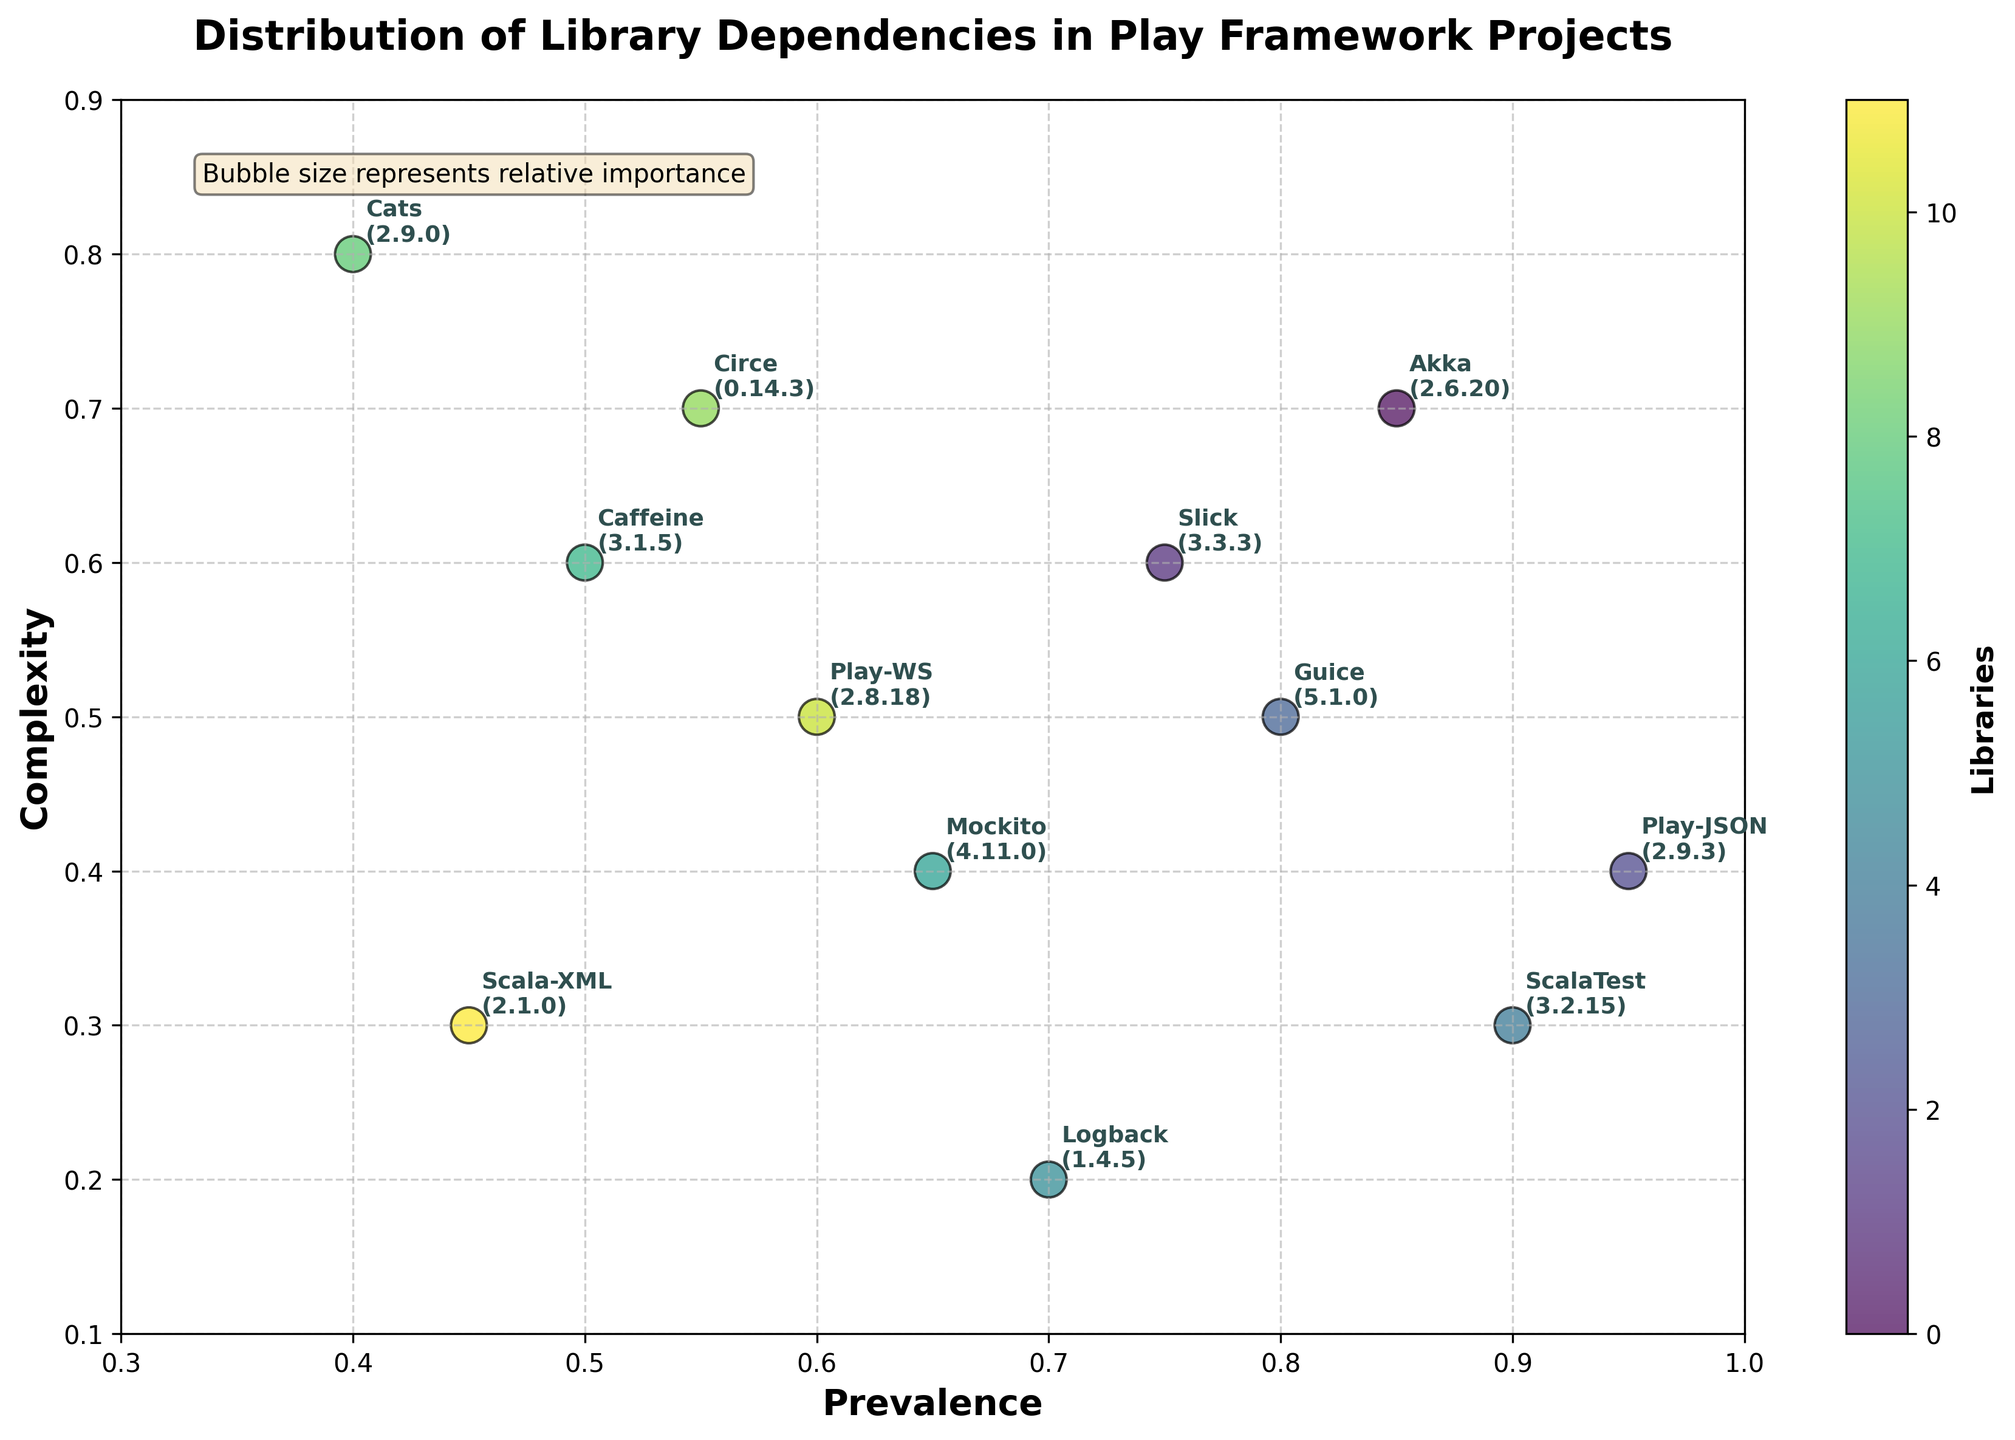What is the title of the plot? The plot's title is prominently displayed at the top center of the figure.
Answer: Distribution of Library Dependencies in Play Framework Projects Which library has the highest prevalence and what is its prevalence value? The label close to the highest point on the x-axis (Prevalence) should be looked at. Looking at the end of the prevalence axis, Play-JSON is the library with the highest prevalence.
Answer: Play-JSON, 0.95 What is the range of complexity values depicted in the plot? Look at the minimum and maximum values on the y-axis (Complexity) to determine the range. Values start from just above 0.1 and go up to just below 0.9.
Answer: 0.1 to 0.9 Which library has the lowest complexity and what is its complexity value? Locate the point that has the lowest position on the y-axis. Logback is the library with the lowest complexity, indicated by its position closest to the bottom of the complexity axis.
Answer: Logback, 0.2 How many libraries have a prevalence greater than 0.8? Identify the points on the plot with prevalence (x-axis) values greater than 0.8. Akka, Play-JSON, Guice, and ScalaTest all have prevalence greater than 0.8, so there are four such libraries.
Answer: 4 Which libraries are at or close to the center of the plot in terms of prevalence and complexity? Find points that are mid-way on both axes. Caffeine and Play-WS appear near the center of the plot.
Answer: Caffeine, Play-WS What is the combined prevalence of Akka and ScalaTest? Look at the prevalence values for Akka and ScalaTest. Adding these values: 0.85 (Akka) + 0.9 (ScalaTest) = 1.75.
Answer: 1.75 Which library has both one of the lowest complexities and one of the highest prevalences? Find points where prevalence is high and complexity is low. ScalaTest stands out with a very low complexity and high prevalence.
Answer: ScalaTest Which library has a relatively high complexity but moderate prevalence, and what are those values? Look for a point that is high on the y-axis but moderate on the x-axis. Cats has a high complexity of 0.8 and a moderate prevalence of 0.4.
Answer: Cats, 0.4 prevalence, 0.8 complexity What is unique about the circular points represented on this plot? This can be inferred from the look of the plot with all circular points. They are color-coded and the size represents their relative importance, as indicated in the text box in the plot.
Answer: They are colored and sized to represent different libraries and their relative importance 